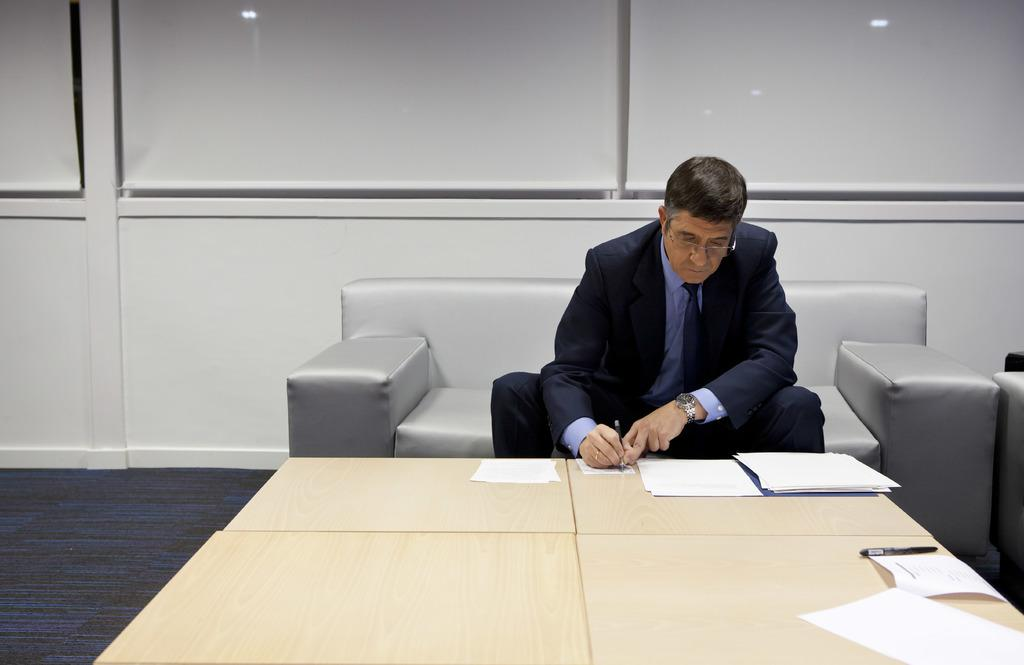Who is present in the image? There is a person in the image. What is the person doing in the image? The person is sitting on a couch and writing on a paper. Where is the paper located in the image? The paper is on a table. What type of cord is being used to connect the building to the railway in the image? There is no building or railway present in the image; it features a person sitting on a couch and writing on a paper. 